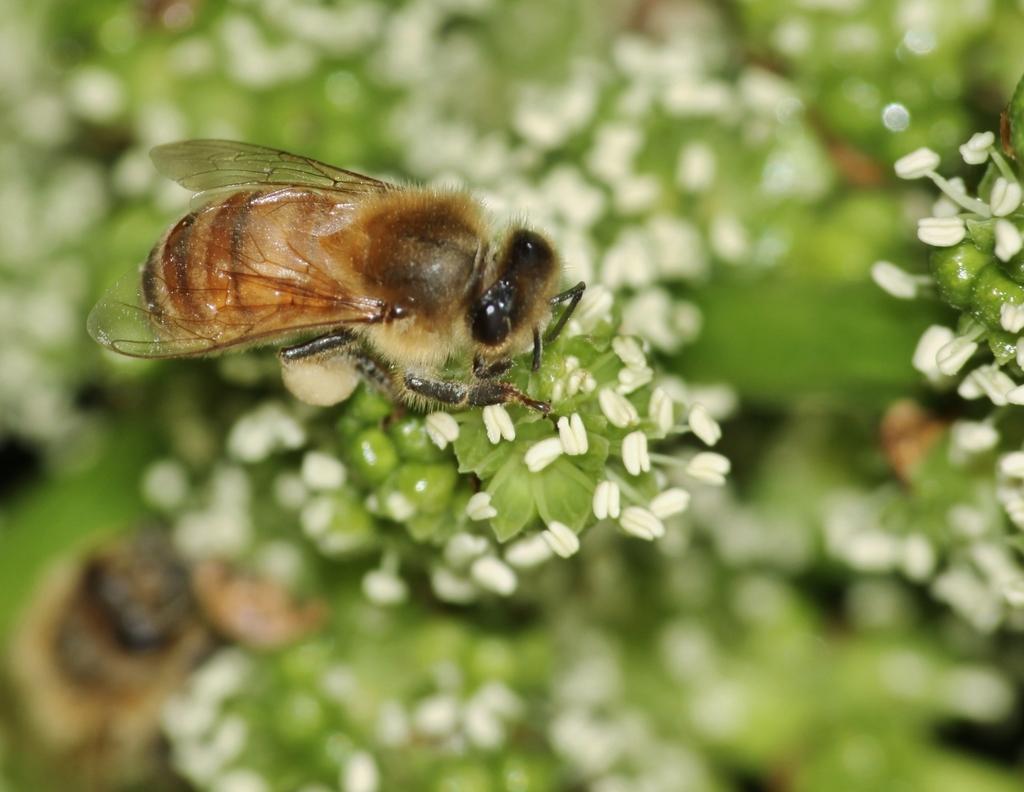In one or two sentences, can you explain what this image depicts? In this picture, we can see a few insects, plants with buds, and the blurred background. 